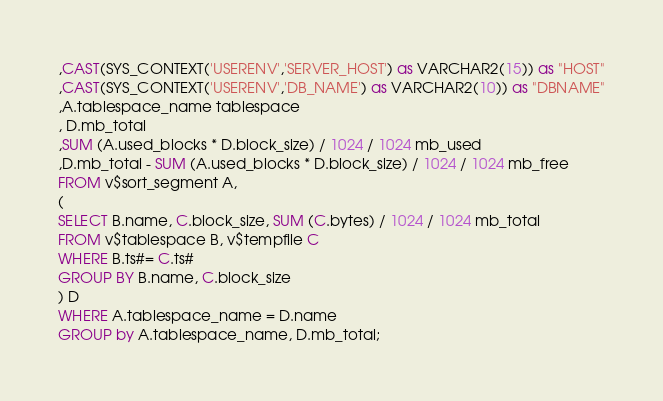Convert code to text. <code><loc_0><loc_0><loc_500><loc_500><_SQL_>,CAST(SYS_CONTEXT('USERENV','SERVER_HOST') as VARCHAR2(15)) as "HOST"
,CAST(SYS_CONTEXT('USERENV','DB_NAME') as VARCHAR2(10)) as "DBNAME"
,A.tablespace_name tablespace
, D.mb_total
,SUM (A.used_blocks * D.block_size) / 1024 / 1024 mb_used
,D.mb_total - SUM (A.used_blocks * D.block_size) / 1024 / 1024 mb_free
FROM v$sort_segment A,
(
SELECT B.name, C.block_size, SUM (C.bytes) / 1024 / 1024 mb_total
FROM v$tablespace B, v$tempfile C
WHERE B.ts#= C.ts#
GROUP BY B.name, C.block_size
) D
WHERE A.tablespace_name = D.name
GROUP by A.tablespace_name, D.mb_total;

</code> 